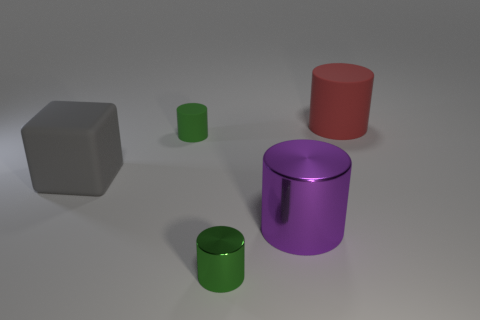What shape is the red matte object that is the same size as the gray object?
Offer a very short reply. Cylinder. How many objects are either big green shiny cylinders or large matte things that are behind the gray rubber object?
Ensure brevity in your answer.  1. Do the tiny metallic object and the tiny matte object have the same color?
Your answer should be very brief. Yes. What number of tiny green cylinders are on the left side of the tiny green metal cylinder?
Your answer should be compact. 1. The other tiny cylinder that is the same material as the purple cylinder is what color?
Make the answer very short. Green. How many metal things are either large brown cylinders or gray blocks?
Your response must be concise. 0. Do the large gray object and the purple object have the same material?
Your response must be concise. No. The large matte object in front of the red cylinder has what shape?
Offer a very short reply. Cube. Is there a tiny green metal object that is right of the large cylinder that is behind the gray rubber object?
Your answer should be very brief. No. Is there a cyan thing of the same size as the purple metallic object?
Provide a succinct answer. No. 